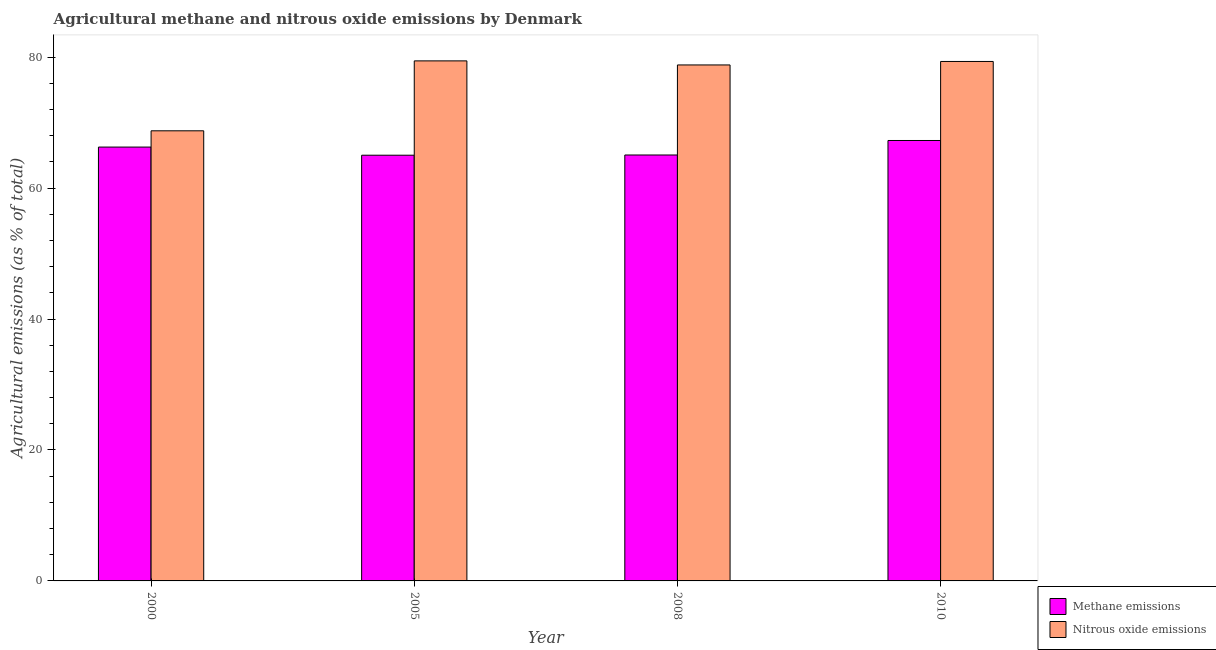How many different coloured bars are there?
Provide a short and direct response. 2. Are the number of bars per tick equal to the number of legend labels?
Offer a very short reply. Yes. Are the number of bars on each tick of the X-axis equal?
Provide a short and direct response. Yes. How many bars are there on the 4th tick from the left?
Give a very brief answer. 2. How many bars are there on the 2nd tick from the right?
Make the answer very short. 2. What is the label of the 4th group of bars from the left?
Keep it short and to the point. 2010. In how many cases, is the number of bars for a given year not equal to the number of legend labels?
Offer a very short reply. 0. What is the amount of nitrous oxide emissions in 2008?
Your response must be concise. 78.82. Across all years, what is the maximum amount of nitrous oxide emissions?
Your response must be concise. 79.44. Across all years, what is the minimum amount of methane emissions?
Give a very brief answer. 65.03. What is the total amount of methane emissions in the graph?
Your answer should be very brief. 263.65. What is the difference between the amount of nitrous oxide emissions in 2005 and that in 2010?
Offer a terse response. 0.09. What is the difference between the amount of nitrous oxide emissions in 2000 and the amount of methane emissions in 2010?
Offer a very short reply. -10.59. What is the average amount of methane emissions per year?
Your response must be concise. 65.91. In how many years, is the amount of nitrous oxide emissions greater than 52 %?
Your answer should be very brief. 4. What is the ratio of the amount of nitrous oxide emissions in 2000 to that in 2005?
Your answer should be compact. 0.87. Is the difference between the amount of nitrous oxide emissions in 2005 and 2010 greater than the difference between the amount of methane emissions in 2005 and 2010?
Offer a very short reply. No. What is the difference between the highest and the second highest amount of methane emissions?
Ensure brevity in your answer.  1.01. What is the difference between the highest and the lowest amount of nitrous oxide emissions?
Your response must be concise. 10.68. In how many years, is the amount of nitrous oxide emissions greater than the average amount of nitrous oxide emissions taken over all years?
Ensure brevity in your answer.  3. What does the 2nd bar from the left in 2008 represents?
Make the answer very short. Nitrous oxide emissions. What does the 1st bar from the right in 2010 represents?
Your answer should be compact. Nitrous oxide emissions. How many bars are there?
Give a very brief answer. 8. Are all the bars in the graph horizontal?
Offer a very short reply. No. How many years are there in the graph?
Your answer should be very brief. 4. Where does the legend appear in the graph?
Offer a terse response. Bottom right. How are the legend labels stacked?
Offer a terse response. Vertical. What is the title of the graph?
Offer a very short reply. Agricultural methane and nitrous oxide emissions by Denmark. What is the label or title of the X-axis?
Provide a short and direct response. Year. What is the label or title of the Y-axis?
Ensure brevity in your answer.  Agricultural emissions (as % of total). What is the Agricultural emissions (as % of total) of Methane emissions in 2000?
Provide a succinct answer. 66.27. What is the Agricultural emissions (as % of total) in Nitrous oxide emissions in 2000?
Make the answer very short. 68.76. What is the Agricultural emissions (as % of total) of Methane emissions in 2005?
Keep it short and to the point. 65.03. What is the Agricultural emissions (as % of total) of Nitrous oxide emissions in 2005?
Make the answer very short. 79.44. What is the Agricultural emissions (as % of total) of Methane emissions in 2008?
Offer a terse response. 65.06. What is the Agricultural emissions (as % of total) in Nitrous oxide emissions in 2008?
Your answer should be very brief. 78.82. What is the Agricultural emissions (as % of total) of Methane emissions in 2010?
Your answer should be very brief. 67.28. What is the Agricultural emissions (as % of total) in Nitrous oxide emissions in 2010?
Provide a short and direct response. 79.35. Across all years, what is the maximum Agricultural emissions (as % of total) of Methane emissions?
Provide a short and direct response. 67.28. Across all years, what is the maximum Agricultural emissions (as % of total) in Nitrous oxide emissions?
Give a very brief answer. 79.44. Across all years, what is the minimum Agricultural emissions (as % of total) of Methane emissions?
Provide a short and direct response. 65.03. Across all years, what is the minimum Agricultural emissions (as % of total) in Nitrous oxide emissions?
Provide a succinct answer. 68.76. What is the total Agricultural emissions (as % of total) in Methane emissions in the graph?
Ensure brevity in your answer.  263.65. What is the total Agricultural emissions (as % of total) of Nitrous oxide emissions in the graph?
Your answer should be very brief. 306.37. What is the difference between the Agricultural emissions (as % of total) in Methane emissions in 2000 and that in 2005?
Offer a very short reply. 1.24. What is the difference between the Agricultural emissions (as % of total) of Nitrous oxide emissions in 2000 and that in 2005?
Provide a short and direct response. -10.68. What is the difference between the Agricultural emissions (as % of total) of Methane emissions in 2000 and that in 2008?
Provide a short and direct response. 1.21. What is the difference between the Agricultural emissions (as % of total) in Nitrous oxide emissions in 2000 and that in 2008?
Offer a terse response. -10.06. What is the difference between the Agricultural emissions (as % of total) in Methane emissions in 2000 and that in 2010?
Ensure brevity in your answer.  -1.01. What is the difference between the Agricultural emissions (as % of total) of Nitrous oxide emissions in 2000 and that in 2010?
Your response must be concise. -10.59. What is the difference between the Agricultural emissions (as % of total) of Methane emissions in 2005 and that in 2008?
Keep it short and to the point. -0.03. What is the difference between the Agricultural emissions (as % of total) of Nitrous oxide emissions in 2005 and that in 2008?
Offer a very short reply. 0.62. What is the difference between the Agricultural emissions (as % of total) of Methane emissions in 2005 and that in 2010?
Offer a terse response. -2.25. What is the difference between the Agricultural emissions (as % of total) of Nitrous oxide emissions in 2005 and that in 2010?
Keep it short and to the point. 0.09. What is the difference between the Agricultural emissions (as % of total) of Methane emissions in 2008 and that in 2010?
Your response must be concise. -2.21. What is the difference between the Agricultural emissions (as % of total) of Nitrous oxide emissions in 2008 and that in 2010?
Ensure brevity in your answer.  -0.53. What is the difference between the Agricultural emissions (as % of total) in Methane emissions in 2000 and the Agricultural emissions (as % of total) in Nitrous oxide emissions in 2005?
Give a very brief answer. -13.17. What is the difference between the Agricultural emissions (as % of total) of Methane emissions in 2000 and the Agricultural emissions (as % of total) of Nitrous oxide emissions in 2008?
Keep it short and to the point. -12.55. What is the difference between the Agricultural emissions (as % of total) in Methane emissions in 2000 and the Agricultural emissions (as % of total) in Nitrous oxide emissions in 2010?
Provide a succinct answer. -13.08. What is the difference between the Agricultural emissions (as % of total) of Methane emissions in 2005 and the Agricultural emissions (as % of total) of Nitrous oxide emissions in 2008?
Keep it short and to the point. -13.79. What is the difference between the Agricultural emissions (as % of total) of Methane emissions in 2005 and the Agricultural emissions (as % of total) of Nitrous oxide emissions in 2010?
Ensure brevity in your answer.  -14.32. What is the difference between the Agricultural emissions (as % of total) of Methane emissions in 2008 and the Agricultural emissions (as % of total) of Nitrous oxide emissions in 2010?
Provide a short and direct response. -14.29. What is the average Agricultural emissions (as % of total) of Methane emissions per year?
Offer a very short reply. 65.91. What is the average Agricultural emissions (as % of total) of Nitrous oxide emissions per year?
Make the answer very short. 76.59. In the year 2000, what is the difference between the Agricultural emissions (as % of total) of Methane emissions and Agricultural emissions (as % of total) of Nitrous oxide emissions?
Offer a very short reply. -2.49. In the year 2005, what is the difference between the Agricultural emissions (as % of total) of Methane emissions and Agricultural emissions (as % of total) of Nitrous oxide emissions?
Your answer should be very brief. -14.41. In the year 2008, what is the difference between the Agricultural emissions (as % of total) of Methane emissions and Agricultural emissions (as % of total) of Nitrous oxide emissions?
Provide a succinct answer. -13.76. In the year 2010, what is the difference between the Agricultural emissions (as % of total) in Methane emissions and Agricultural emissions (as % of total) in Nitrous oxide emissions?
Offer a terse response. -12.07. What is the ratio of the Agricultural emissions (as % of total) of Methane emissions in 2000 to that in 2005?
Offer a very short reply. 1.02. What is the ratio of the Agricultural emissions (as % of total) of Nitrous oxide emissions in 2000 to that in 2005?
Offer a terse response. 0.87. What is the ratio of the Agricultural emissions (as % of total) of Methane emissions in 2000 to that in 2008?
Your response must be concise. 1.02. What is the ratio of the Agricultural emissions (as % of total) of Nitrous oxide emissions in 2000 to that in 2008?
Offer a terse response. 0.87. What is the ratio of the Agricultural emissions (as % of total) in Nitrous oxide emissions in 2000 to that in 2010?
Offer a terse response. 0.87. What is the ratio of the Agricultural emissions (as % of total) in Methane emissions in 2005 to that in 2008?
Your answer should be very brief. 1. What is the ratio of the Agricultural emissions (as % of total) in Nitrous oxide emissions in 2005 to that in 2008?
Keep it short and to the point. 1.01. What is the ratio of the Agricultural emissions (as % of total) of Methane emissions in 2005 to that in 2010?
Provide a short and direct response. 0.97. What is the ratio of the Agricultural emissions (as % of total) of Methane emissions in 2008 to that in 2010?
Your answer should be very brief. 0.97. What is the difference between the highest and the second highest Agricultural emissions (as % of total) in Nitrous oxide emissions?
Offer a terse response. 0.09. What is the difference between the highest and the lowest Agricultural emissions (as % of total) of Methane emissions?
Offer a very short reply. 2.25. What is the difference between the highest and the lowest Agricultural emissions (as % of total) in Nitrous oxide emissions?
Provide a succinct answer. 10.68. 